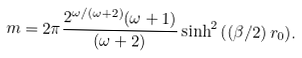Convert formula to latex. <formula><loc_0><loc_0><loc_500><loc_500>m = 2 \pi \frac { 2 ^ { \omega / { ( \omega + 2 ) } } ( \omega + 1 ) } { ( \omega + 2 ) } \sinh ^ { 2 } { \left ( ( \beta / 2 ) \, r _ { 0 } \right ) } .</formula> 